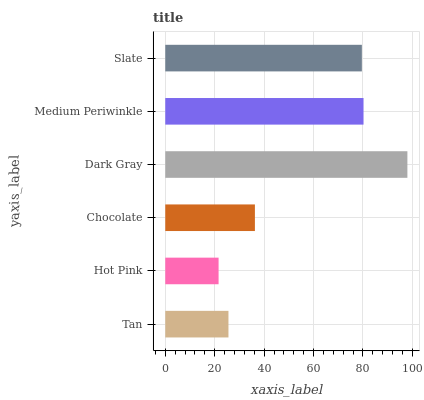Is Hot Pink the minimum?
Answer yes or no. Yes. Is Dark Gray the maximum?
Answer yes or no. Yes. Is Chocolate the minimum?
Answer yes or no. No. Is Chocolate the maximum?
Answer yes or no. No. Is Chocolate greater than Hot Pink?
Answer yes or no. Yes. Is Hot Pink less than Chocolate?
Answer yes or no. Yes. Is Hot Pink greater than Chocolate?
Answer yes or no. No. Is Chocolate less than Hot Pink?
Answer yes or no. No. Is Slate the high median?
Answer yes or no. Yes. Is Chocolate the low median?
Answer yes or no. Yes. Is Dark Gray the high median?
Answer yes or no. No. Is Tan the low median?
Answer yes or no. No. 